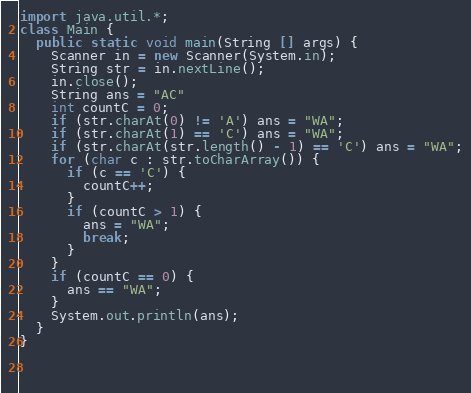Convert code to text. <code><loc_0><loc_0><loc_500><loc_500><_Java_>import java.util.*;
class Main {
  public static void main(String [] args) {
    Scanner in = new Scanner(System.in);
    String str = in.nextLine();
    in.close();
    String ans = "AC"
    int countC = 0;
    if (str.charAt(0) != 'A') ans = "WA";
    if (str.charAt(1) == 'C') ans = "WA";
    if (str.charAt(str.length() - 1) == 'C') ans = "WA";
    for (char c : str.toCharArray()) {
      if (c == 'C') {
        countC++;
      }
      if (countC > 1) {
        ans = "WA";
        break;
      }
    }
    if (countC == 0) {
      ans == "WA";
    }
    System.out.println(ans);
  }
}
    
      
      </code> 